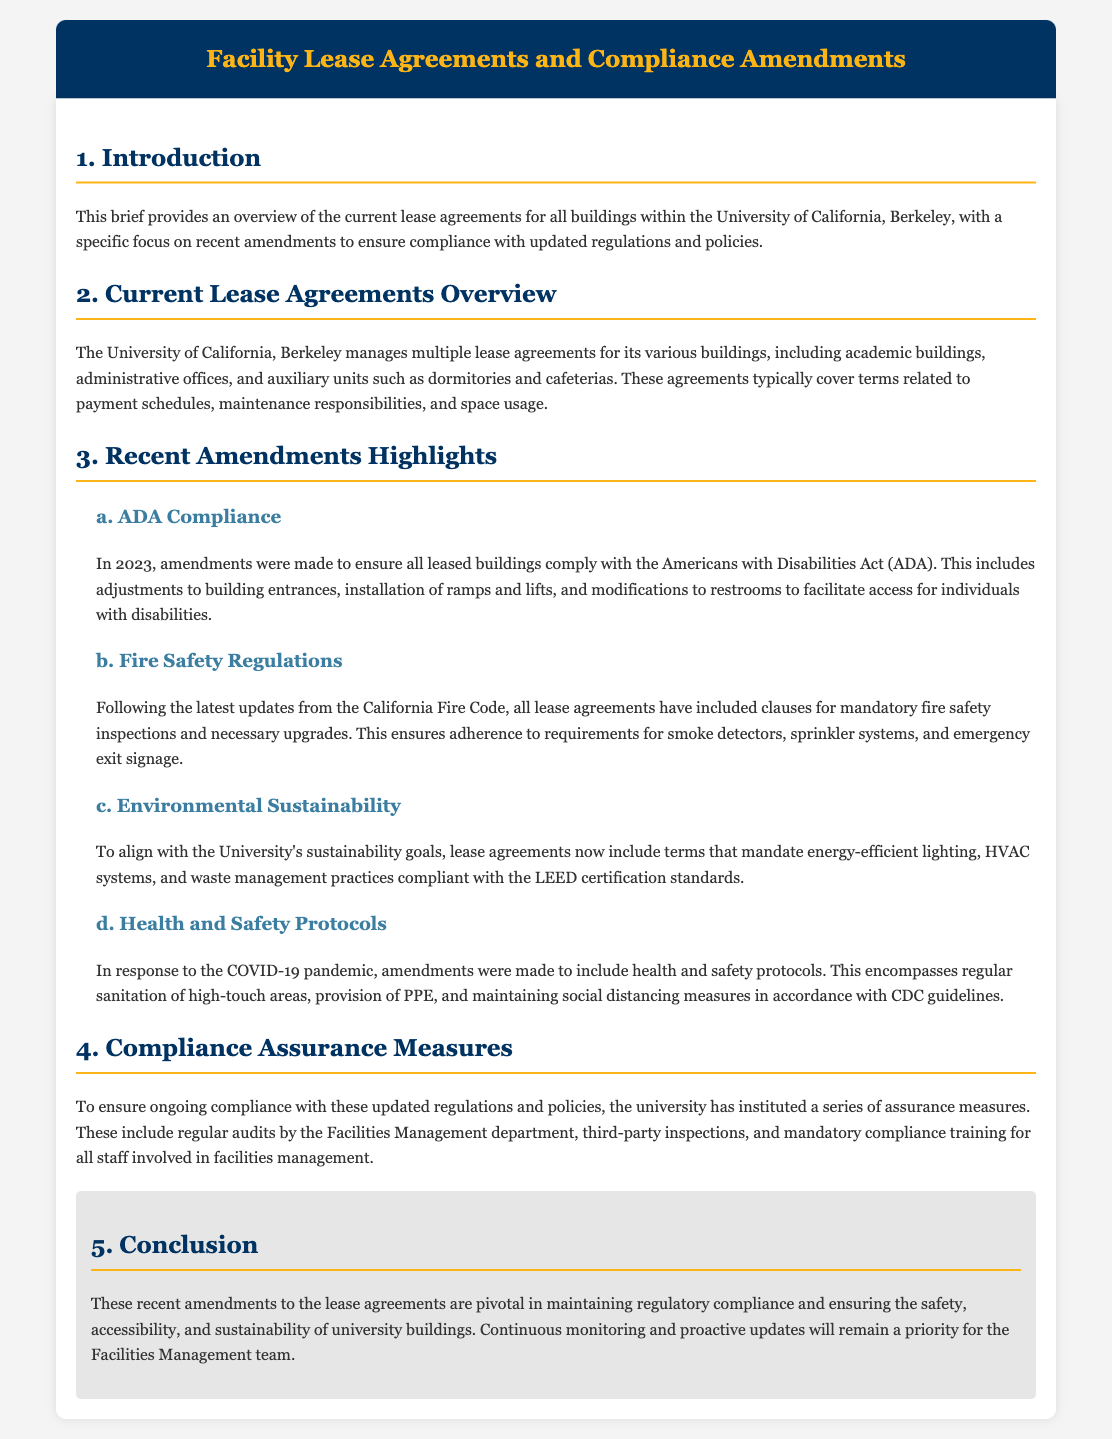What is the title of the document? The title of the document is the main heading at the top, indicating the subject matter covered.
Answer: Facility Lease Agreements and Compliance Amendments What year were amendments made for ADA compliance? The year in which amendments were made for ADA compliance is stated in the section detailing recent amendments.
Answer: 2023 Which act is referenced for disability compliance? The document mentions a specific act that pertains to accessibility regulations.
Answer: Americans with Disabilities Act (ADA) What safety inspections are mandated by the recent amendments? The document specifies inspections that are required for compliance with updated regulations regarding safety.
Answer: Fire safety inspections What sustainability certification standards are mentioned? The document refers to standards that relate to environmental practices in the lease agreements.
Answer: LEED certification standards How many assurance measures are mentioned for compliance? The document discusses the assurance measures implemented for ongoing compliance, which is a specific number stated.
Answer: Three What department is responsible for regular audits? The entity responsible for conducting regular audits is mentioned in connection with compliance assurance.
Answer: Facilities Management department What health protocol is included in the amendments? The document outlines a specific health protocol that is part of the recent amendments due to a public health situation.
Answer: Regular sanitation of high-touch areas What is the main focus of the document? The primary subject of the document is outlined in the introduction, summarizing its overall objective.
Answer: Overview of current lease agreements and amendments for compliance 